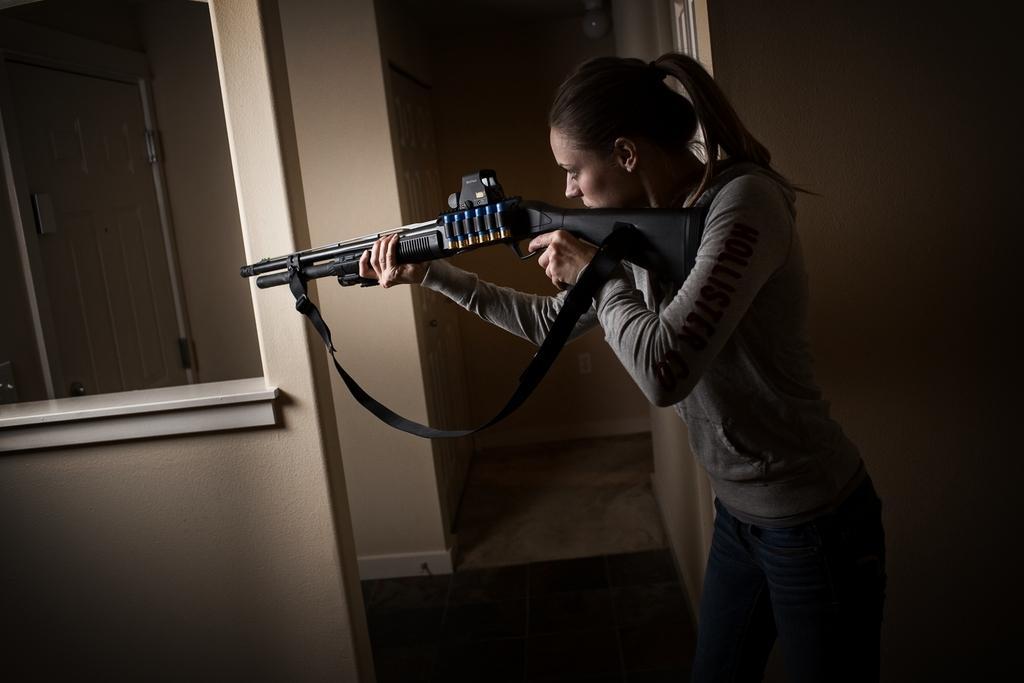Describe this image in one or two sentences. This image consists of a woman holding a gun. She is wearing a gray T-shirt. It looks like it is clicked inside the house. In the background, we can see walls. On the left, there is a stand. At the bottom, there is a floor. 